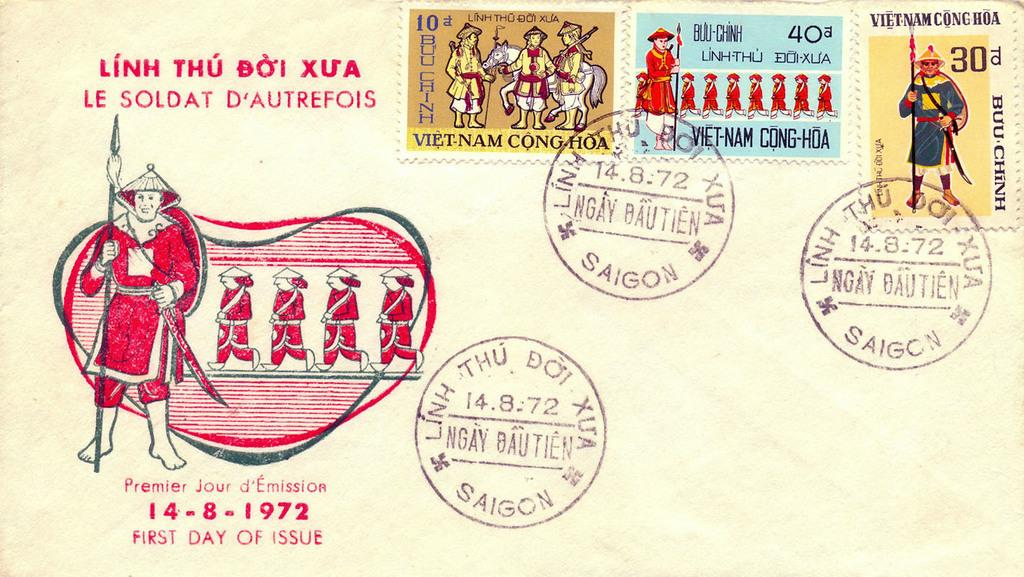What is the main object in the image? There is a card in the image. What can be seen on the card? There are stamps and depictions of persons on the card. Can you tell me how many tigers are depicted on the card? There is no tiger depicted on the card; it features stamps and depictions of persons. What type of boat is shown on the card? There is no boat present on the card; it only features stamps and depictions of persons. 